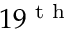Convert formula to latex. <formula><loc_0><loc_0><loc_500><loc_500>1 9 ^ { t h }</formula> 